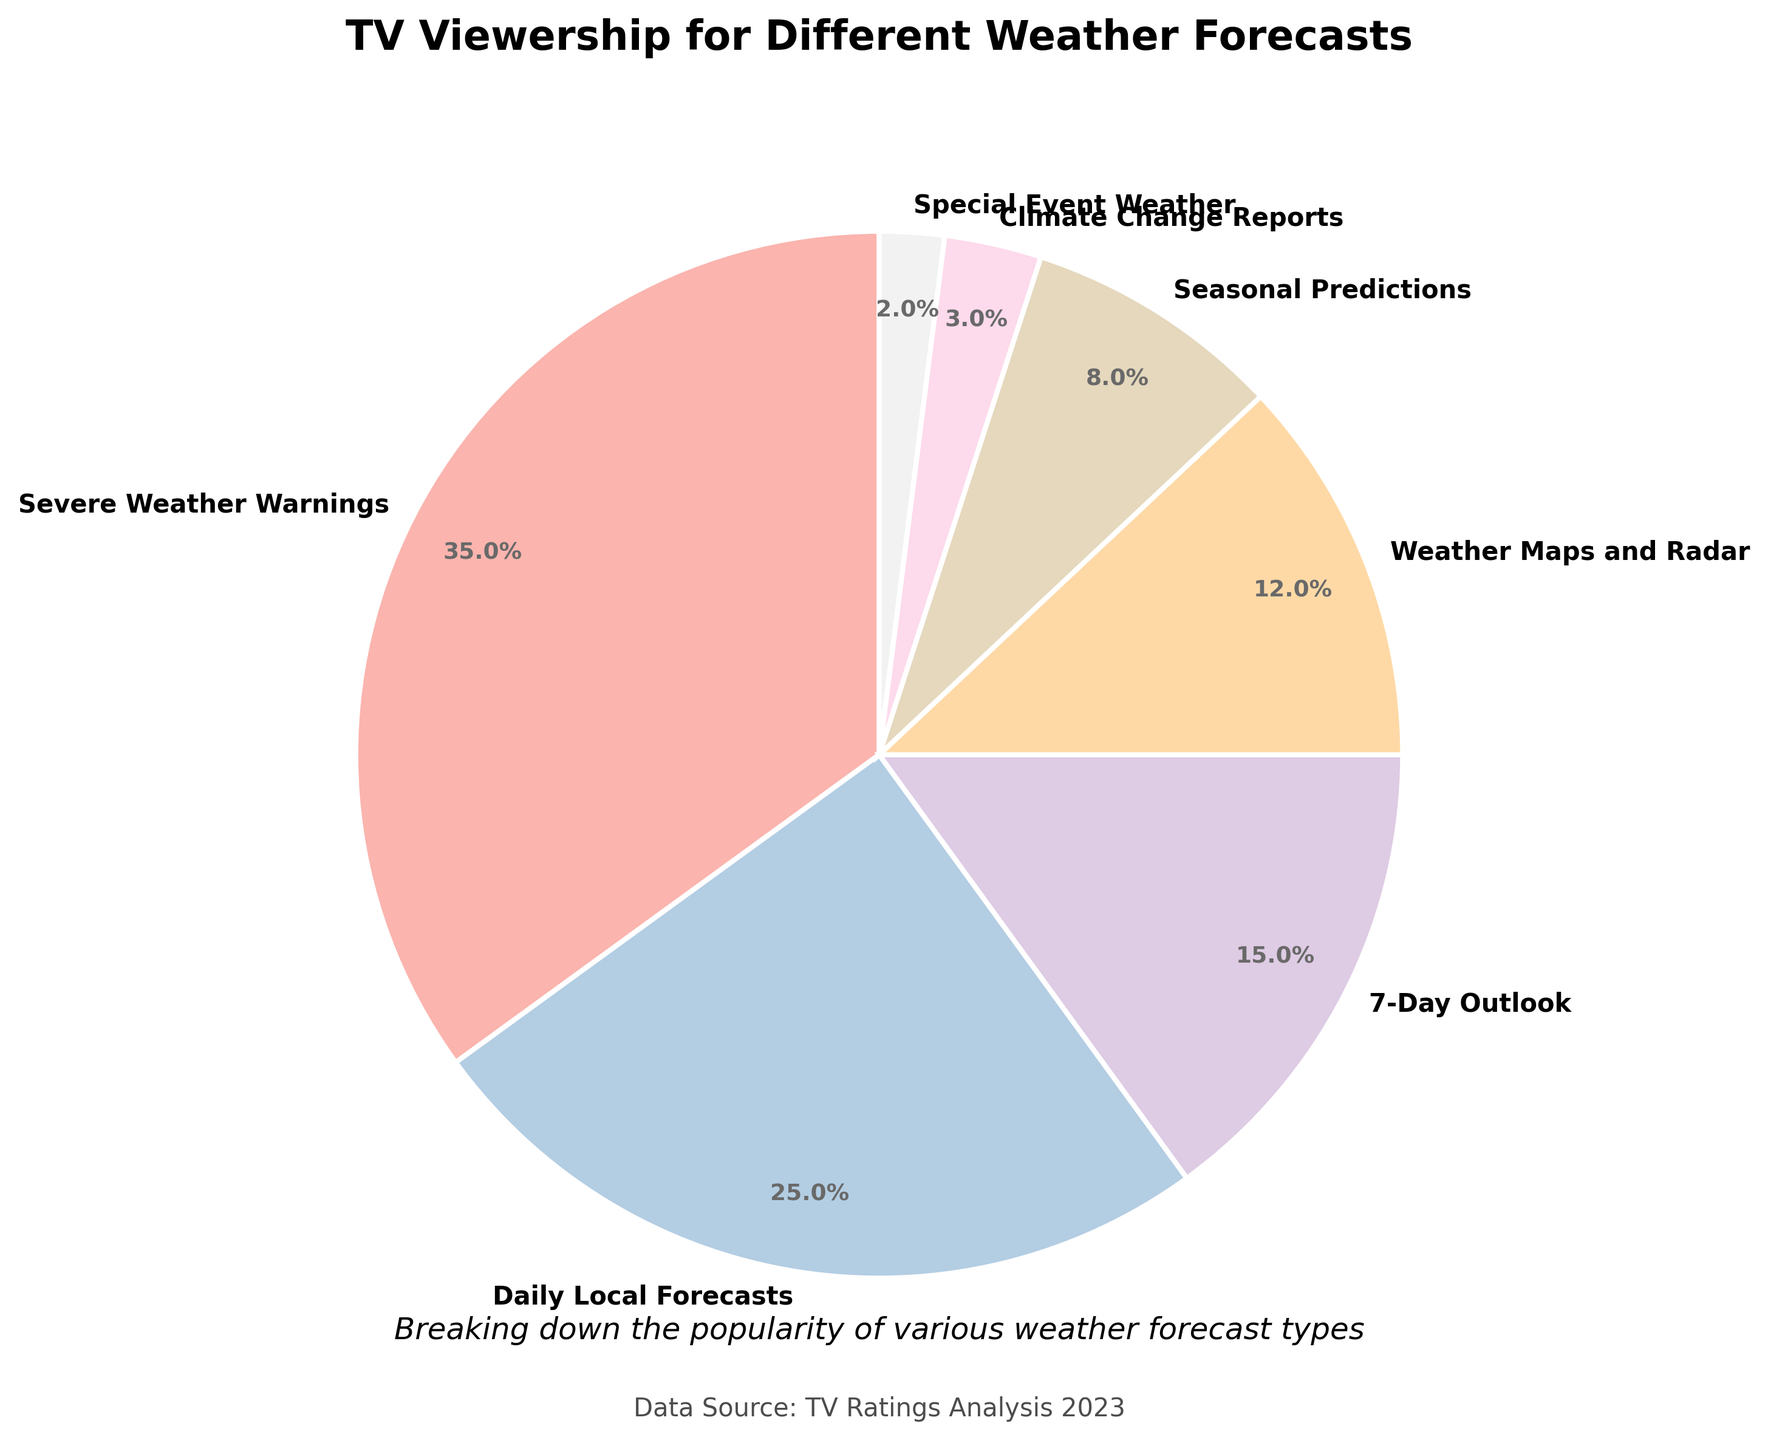What percentage of viewership do Severe Weather Warnings and Daily Local Forecasts account for combined? To find the combined viewership percentage for Severe Weather Warnings and Daily Local Forecasts, add their individual percentages: 35% (Severe Weather Warnings) + 25% (Daily Local Forecasts) = 60%.
Answer: 60% Which weather forecast type has the lowest viewership percentage, and what is that percentage? Among the weather forecast types, Special Event Weather has the lowest viewership percentage, which can be directly seen in the figure as 2%.
Answer: Special Event Weather, 2% How does the viewership for Weather Maps and Radar compare to the viewership for Seasonal Predictions? To compare these two, note their viewership percentages: Weather Maps and Radar is 12%, while Seasonal Predictions is 8%. By numerical comparison, Weather Maps and Radar has a higher viewership.
Answer: Weather Maps and Radar has higher viewership What is the difference in viewership percentage between Severe Weather Warnings and Climate Change Reports? Subtract the percentage of Climate Change Reports from Severe Weather Warnings: 35% (Severe Weather Warnings) - 3% (Climate Change Reports) = 32%.
Answer: 32% List the weather forecast types in descending order based on their viewership percentages. To order them from highest to lowest, refer to the figure's data: 
Severe Weather Warnings (35%), Daily Local Forecasts (25%), 7-Day Outlook (15%), Weather Maps and Radar (12%), Seasonal Predictions (8%), Climate Change Reports (3%), Special Event Weather (2%).
Answer: Severe Weather Warnings, Daily Local Forecasts, 7-Day Outlook, Weather Maps and Radar, Seasonal Predictions, Climate Change Reports, Special Event Weather What percentage of viewership is attributed to the three least popular weather forecast types combined? Add up the percentages for Climate Change Reports, Special Event Weather, and Seasonal Predictions: 3% (Climate Change Reports) + 2% (Special Event Weather) + 8% (Seasonal Predictions) = 13%.
Answer: 13% Which forecast type has a viewership that is less than half of the 7-Day Outlook's viewership? Identify the types with percentages less than half of 15% (7-Day Outlook): less than 7.5%. Only two types have viewership percentages less than 7.5%: Climate Change Reports (3%) and Special Event Weather (2%).
Answer: Climate Change Reports and Special Event Weather Is the viewership for Seasonal Predictions greater than or less than half the viewership for Daily Local Forecasts? Calculate half of Daily Local Forecasts' percentage: 25% / 2 = 12.5%. Seasonal Predictions has 8%, which is less than 12.5%.
Answer: Less What combined viewership percentage do 7-Day Outlook and Weather Maps and Radar account for? Add the viewership percentages for 7-Day Outlook and Weather Maps and Radar: 15% (7-Day Outlook) + 12% (Weather Maps and Radar) = 27%.
Answer: 27% 